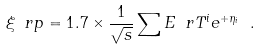<formula> <loc_0><loc_0><loc_500><loc_500>\xi _ { \ } r p = 1 . 7 \times \frac { 1 } { \sqrt { s } } \sum E _ { \ } r T ^ { i } e ^ { + \eta _ { i } } \ .</formula> 